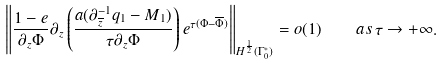<formula> <loc_0><loc_0><loc_500><loc_500>\left \| \frac { 1 - e } { \partial _ { z } \Phi } \partial _ { z } \left ( \frac { a ( \partial ^ { - 1 } _ { \overline { z } } q _ { 1 } - M _ { 1 } ) } { \tau \partial _ { z } \Phi } \right ) e ^ { \tau ( \Phi - \overline { \Phi } ) } \right \| _ { H ^ { \frac { 1 } { 2 } } ( \Gamma _ { 0 } ^ { * } ) } = o ( 1 ) \quad a s \, \tau \rightarrow + \infty .</formula> 